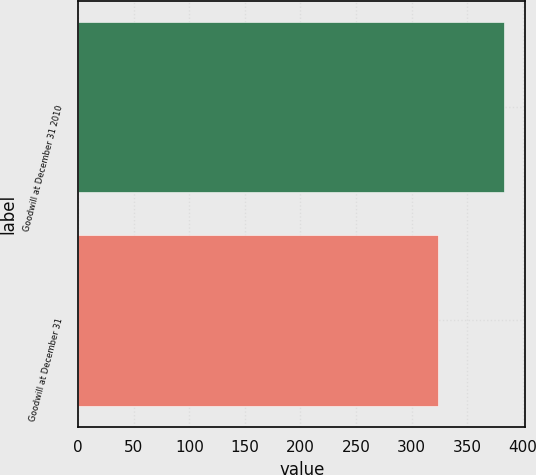Convert chart. <chart><loc_0><loc_0><loc_500><loc_500><bar_chart><fcel>Goodwill at December 31 2010<fcel>Goodwill at December 31<nl><fcel>383<fcel>324<nl></chart> 